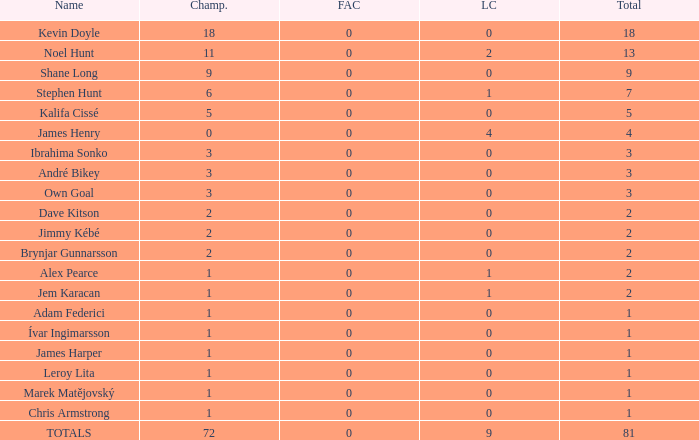What is the championship of Jem Karacan that has a total of 2 and a league cup more than 0? 1.0. 